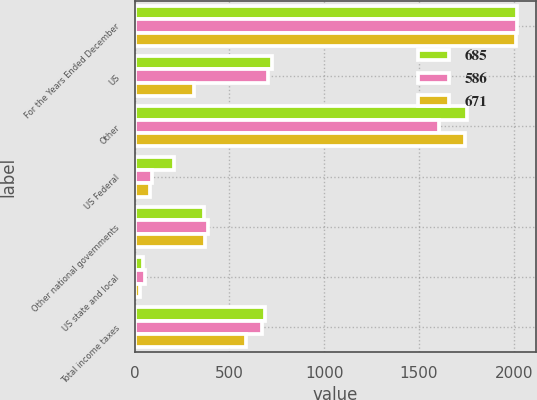Convert chart to OTSL. <chart><loc_0><loc_0><loc_500><loc_500><stacked_bar_chart><ecel><fcel>For the Years Ended December<fcel>US<fcel>Other<fcel>US Federal<fcel>Other national governments<fcel>US state and local<fcel>Total income taxes<nl><fcel>685<fcel>2016<fcel>725<fcel>1755<fcel>208<fcel>366<fcel>43<fcel>685<nl><fcel>586<fcel>2015<fcel>702<fcel>1605<fcel>90<fcel>385<fcel>52<fcel>671<nl><fcel>671<fcel>2014<fcel>313<fcel>1744<fcel>80<fcel>369<fcel>26<fcel>586<nl></chart> 